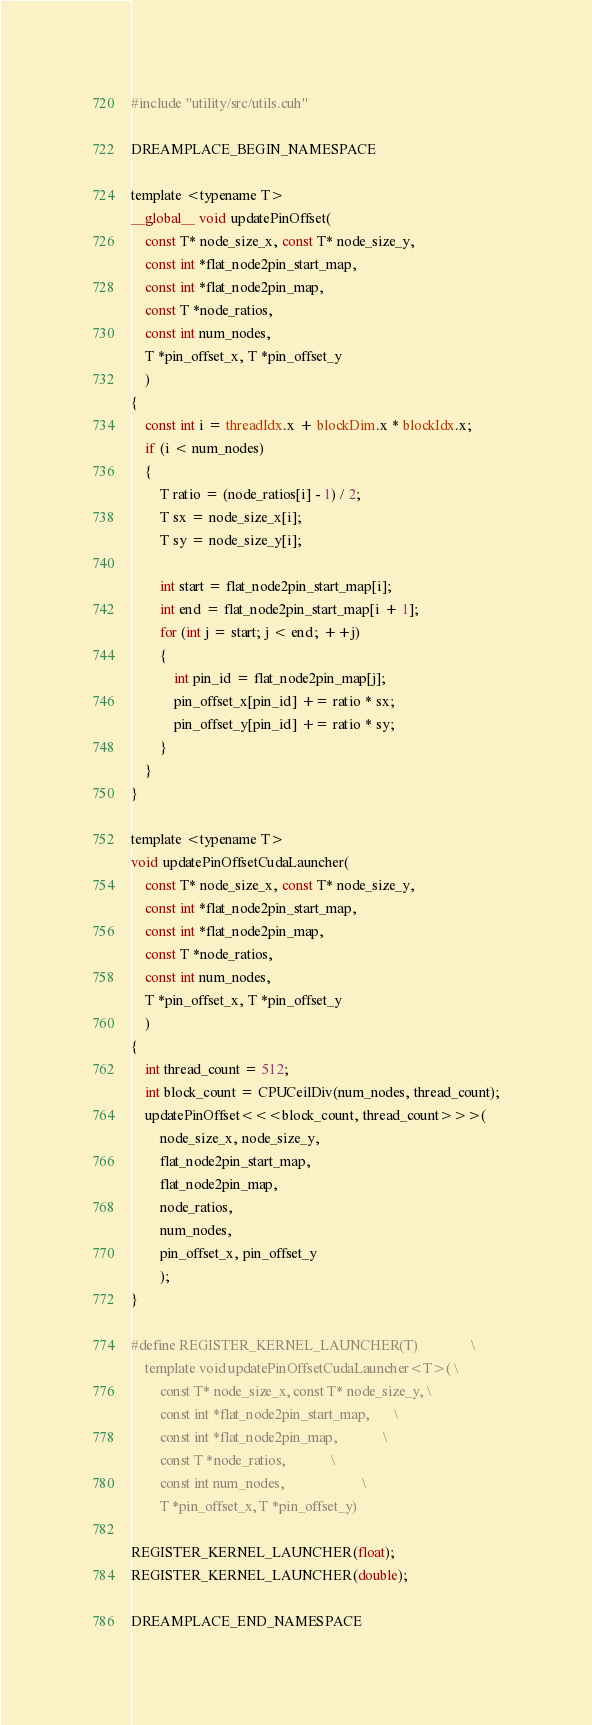<code> <loc_0><loc_0><loc_500><loc_500><_Cuda_>#include "utility/src/utils.cuh"

DREAMPLACE_BEGIN_NAMESPACE

template <typename T>
__global__ void updatePinOffset(
    const T* node_size_x, const T* node_size_y, 
    const int *flat_node2pin_start_map,
    const int *flat_node2pin_map,
    const T *node_ratios,
    const int num_nodes,
    T *pin_offset_x, T *pin_offset_y
    )
{
    const int i = threadIdx.x + blockDim.x * blockIdx.x;
    if (i < num_nodes)
    {
        T ratio = (node_ratios[i] - 1) / 2;
        T sx = node_size_x[i]; 
        T sy = node_size_y[i]; 

        int start = flat_node2pin_start_map[i];
        int end = flat_node2pin_start_map[i + 1];
        for (int j = start; j < end; ++j)
        {
            int pin_id = flat_node2pin_map[j];
            pin_offset_x[pin_id] += ratio * sx;
            pin_offset_y[pin_id] += ratio * sy;
        }
    }
}

template <typename T>
void updatePinOffsetCudaLauncher(
    const T* node_size_x, const T* node_size_y, 
    const int *flat_node2pin_start_map,
    const int *flat_node2pin_map,
    const T *node_ratios,
    const int num_nodes,
    T *pin_offset_x, T *pin_offset_y
    )
{
    int thread_count = 512;
    int block_count = CPUCeilDiv(num_nodes, thread_count);
    updatePinOffset<<<block_count, thread_count>>>(
        node_size_x, node_size_y, 
        flat_node2pin_start_map,
        flat_node2pin_map,
        node_ratios,
        num_nodes,
        pin_offset_x, pin_offset_y
        );
}

#define REGISTER_KERNEL_LAUNCHER(T)               \
    template void updatePinOffsetCudaLauncher<T>( \
        const T* node_size_x, const T* node_size_y, \
        const int *flat_node2pin_start_map,       \
        const int *flat_node2pin_map,             \
        const T *node_ratios,             \
        const int num_nodes,                      \
        T *pin_offset_x, T *pin_offset_y)

REGISTER_KERNEL_LAUNCHER(float);
REGISTER_KERNEL_LAUNCHER(double);

DREAMPLACE_END_NAMESPACE
</code> 